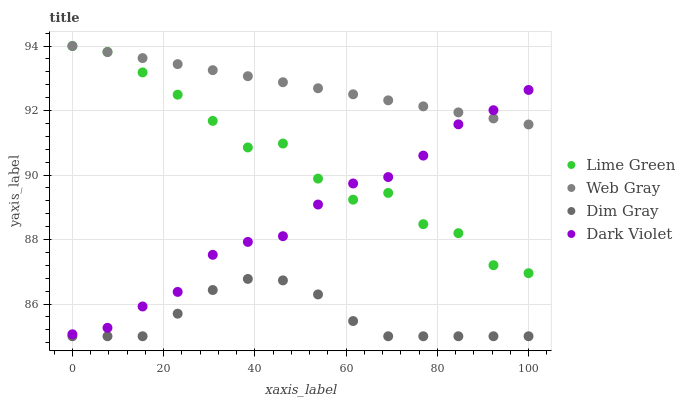Does Dim Gray have the minimum area under the curve?
Answer yes or no. Yes. Does Web Gray have the maximum area under the curve?
Answer yes or no. Yes. Does Lime Green have the minimum area under the curve?
Answer yes or no. No. Does Lime Green have the maximum area under the curve?
Answer yes or no. No. Is Web Gray the smoothest?
Answer yes or no. Yes. Is Lime Green the roughest?
Answer yes or no. Yes. Is Lime Green the smoothest?
Answer yes or no. No. Is Web Gray the roughest?
Answer yes or no. No. Does Dim Gray have the lowest value?
Answer yes or no. Yes. Does Lime Green have the lowest value?
Answer yes or no. No. Does Lime Green have the highest value?
Answer yes or no. Yes. Does Dark Violet have the highest value?
Answer yes or no. No. Is Dim Gray less than Dark Violet?
Answer yes or no. Yes. Is Web Gray greater than Dim Gray?
Answer yes or no. Yes. Does Dark Violet intersect Web Gray?
Answer yes or no. Yes. Is Dark Violet less than Web Gray?
Answer yes or no. No. Is Dark Violet greater than Web Gray?
Answer yes or no. No. Does Dim Gray intersect Dark Violet?
Answer yes or no. No. 